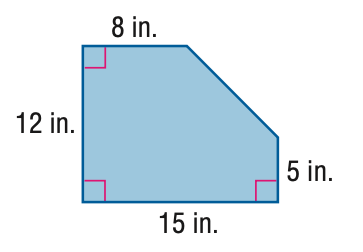Question: Find the area of the figure. Round to the nearest tenth if necessary.
Choices:
A. 24.5
B. 49
C. 155.5
D. 180
Answer with the letter. Answer: C 